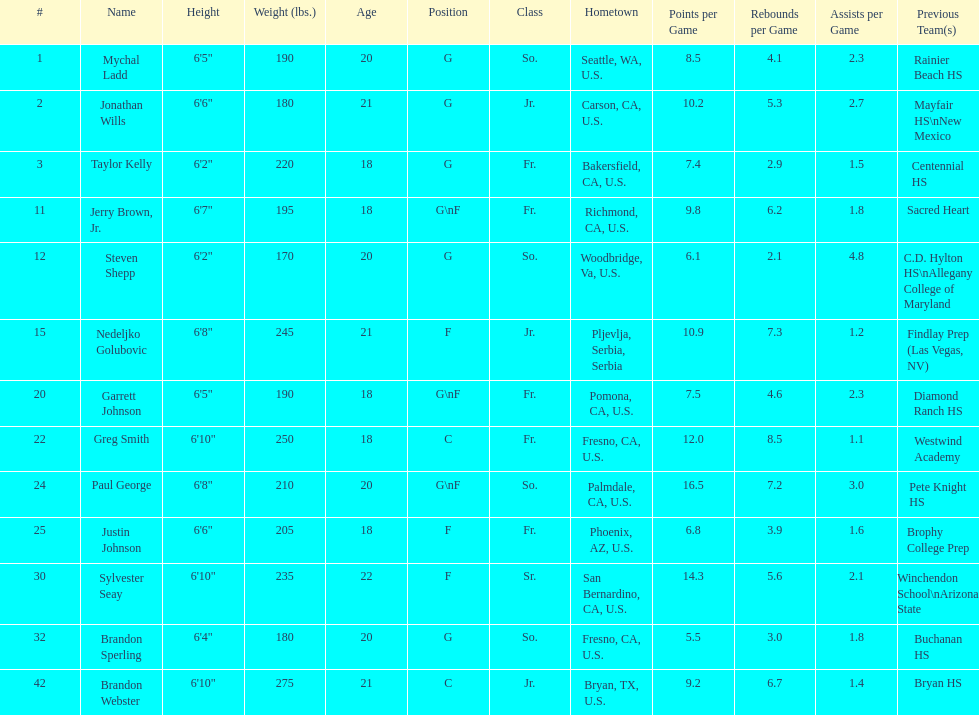Parse the table in full. {'header': ['#', 'Name', 'Height', 'Weight (lbs.)', 'Age', 'Position', 'Class', 'Hometown', 'Points per Game', 'Rebounds per Game', 'Assists per Game', 'Previous Team(s)'], 'rows': [['1', 'Mychal Ladd', '6\'5"', '190', '20', 'G', 'So.', 'Seattle, WA, U.S.', '8.5', '4.1', '2.3', 'Rainier Beach HS'], ['2', 'Jonathan Wills', '6\'6"', '180', '21', 'G', 'Jr.', 'Carson, CA, U.S.', '10.2', '5.3', '2.7', 'Mayfair HS\\nNew Mexico'], ['3', 'Taylor Kelly', '6\'2"', '220', '18', 'G', 'Fr.', 'Bakersfield, CA, U.S.', '7.4', '2.9', '1.5', 'Centennial HS'], ['11', 'Jerry Brown, Jr.', '6\'7"', '195', '18', 'G\\nF', 'Fr.', 'Richmond, CA, U.S.', '9.8', '6.2', '1.8', 'Sacred Heart'], ['12', 'Steven Shepp', '6\'2"', '170', '20', 'G', 'So.', 'Woodbridge, Va, U.S.', '6.1', '2.1', '4.8', 'C.D. Hylton HS\\nAllegany College of Maryland'], ['15', 'Nedeljko Golubovic', '6\'8"', '245', '21', 'F', 'Jr.', 'Pljevlja, Serbia, Serbia', '10.9', '7.3', '1.2', 'Findlay Prep (Las Vegas, NV)'], ['20', 'Garrett Johnson', '6\'5"', '190', '18', 'G\\nF', 'Fr.', 'Pomona, CA, U.S.', '7.5', '4.6', '2.3', 'Diamond Ranch HS'], ['22', 'Greg Smith', '6\'10"', '250', '18', 'C', 'Fr.', 'Fresno, CA, U.S.', '12.0', '8.5', '1.1', 'Westwind Academy'], ['24', 'Paul George', '6\'8"', '210', '20', 'G\\nF', 'So.', 'Palmdale, CA, U.S.', '16.5', '7.2', '3.0', 'Pete Knight HS'], ['25', 'Justin Johnson', '6\'6"', '205', '18', 'F', 'Fr.', 'Phoenix, AZ, U.S.', '6.8', '3.9', '1.6', 'Brophy College Prep'], ['30', 'Sylvester Seay', '6\'10"', '235', '22', 'F', 'Sr.', 'San Bernardino, CA, U.S.', '14.3', '5.6', '2.1', 'Winchendon School\\nArizona State'], ['32', 'Brandon Sperling', '6\'4"', '180', '20', 'G', 'So.', 'Fresno, CA, U.S.', '5.5', '3.0', '1.8', 'Buchanan HS'], ['42', 'Brandon Webster', '6\'10"', '275', '21', 'C', 'Jr.', 'Bryan, TX, U.S.', '9.2', '6.7', '1.4', 'Bryan HS']]} How many players hometowns are outside of california? 5. 